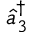<formula> <loc_0><loc_0><loc_500><loc_500>\hat { a } _ { 3 } ^ { \dagger }</formula> 